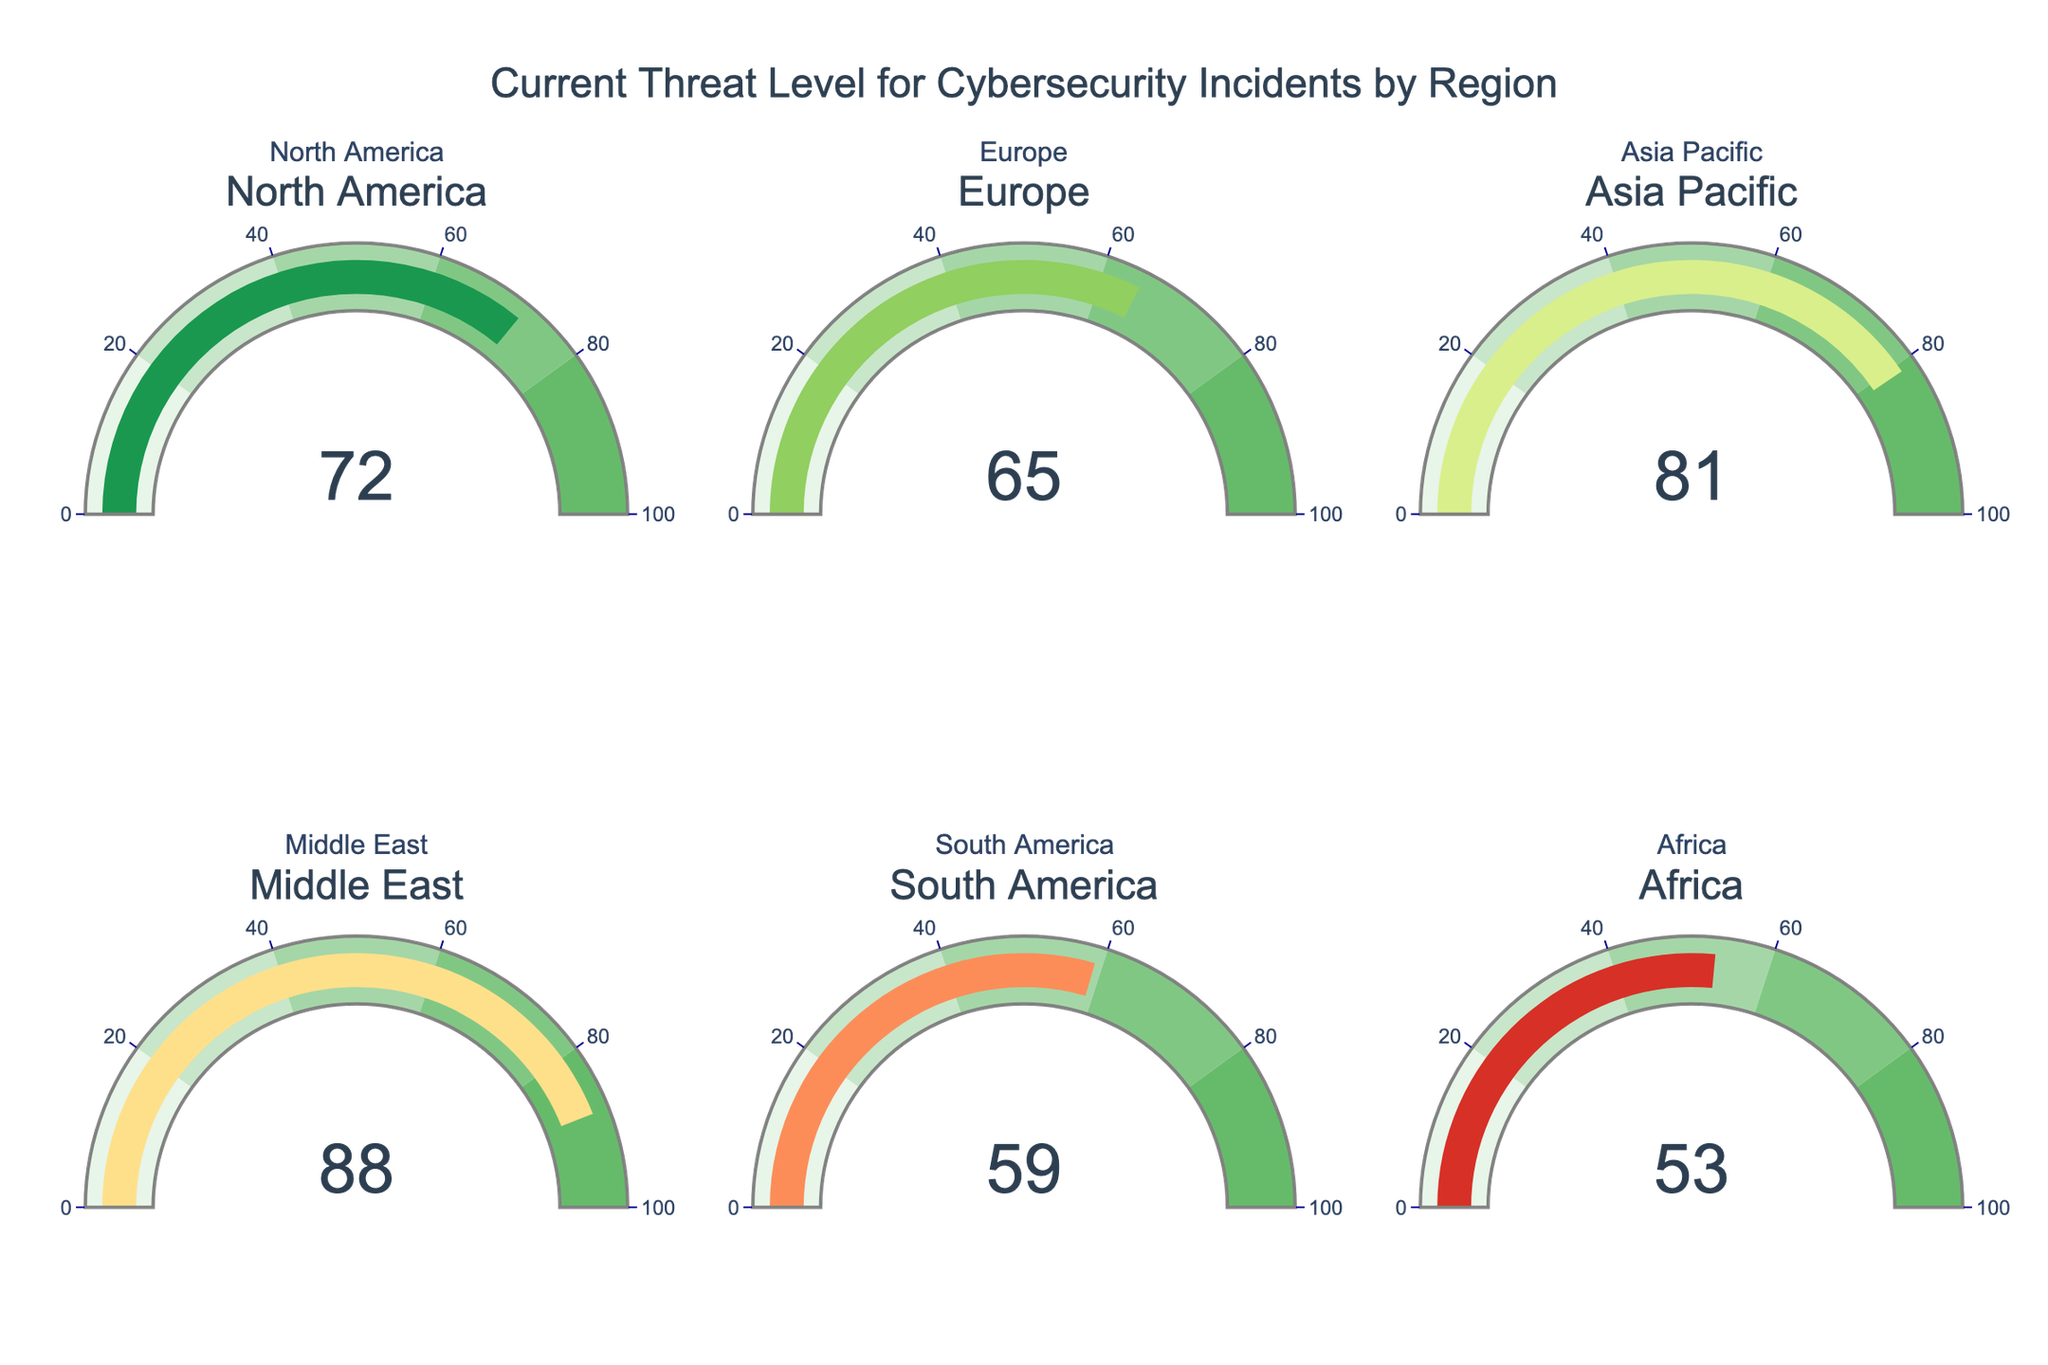What’s the current threat level for North America? The gauge for North America shows the number 72, which indicates its current threat level.
Answer: 72 Which region has the highest threat level? The Middle East has the highest threat level, shown as 88 on its gauge.
Answer: Middle East What’s the difference in threat level between Europe and Asia Pacific? Europe has a threat level of 65, and Asia Pacific has 81. Subtracting 65 from 81 gives 16.
Answer: 16 Which regions have a threat level above 70? North America (72), Asia Pacific (81), and the Middle East (88) all have threat levels above 70, as indicated by their gauges.
Answer: North America, Asia Pacific, Middle East What is the average threat level across all regions? Summing all threat levels: 72 (North America) + 65 (Europe) + 81 (Asia Pacific) + 88 (Middle East) + 59 (South America) + 53 (Africa) = 418. Dividing by the number of regions (6) results in an average of 418 / 6 = 69.67.
Answer: 69.67 Which region has the lowest threat level? Africa has the lowest threat level, which is 53, as indicated by its gauge.
Answer: Africa 